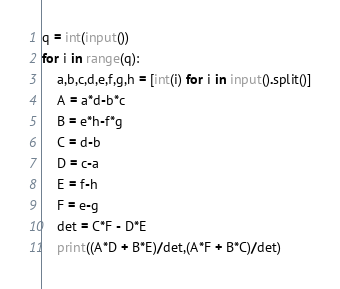<code> <loc_0><loc_0><loc_500><loc_500><_Python_>q = int(input())
for i in range(q):
    a,b,c,d,e,f,g,h = [int(i) for i in input().split()]
    A = a*d-b*c
    B = e*h-f*g
    C = d-b
    D = c-a
    E = f-h
    F = e-g
    det = C*F - D*E
    print((A*D + B*E)/det,(A*F + B*C)/det)</code> 